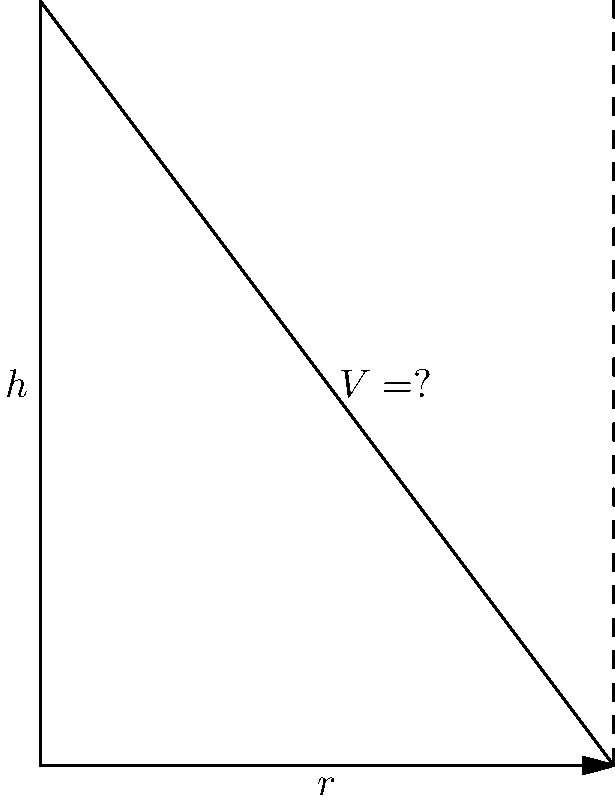Given a cone with radius $r = 3$ cm and height $h = 4$ cm, calculate its volume. Round your answer to two decimal places. To calculate the volume of a cone, we use the formula:

$$V = \frac{1}{3}\pi r^2 h$$

Where:
$V$ is the volume
$r$ is the radius of the base
$h$ is the height of the cone

Let's substitute the given values:

$r = 3$ cm
$h = 4$ cm

Now, let's calculate:

$$V = \frac{1}{3}\pi (3\text{ cm})^2 (4\text{ cm})$$

$$V = \frac{1}{3}\pi (9\text{ cm}^2) (4\text{ cm})$$

$$V = \frac{4}{3}\pi (9\text{ cm}^3)$$

$$V = 12\pi\text{ cm}^3$$

Using $\pi \approx 3.14159$:

$$V \approx 12 * 3.14159\text{ cm}^3$$

$$V \approx 37.69908\text{ cm}^3$$

Rounding to two decimal places:

$$V \approx 37.70\text{ cm}^3$$
Answer: $37.70\text{ cm}^3$ 